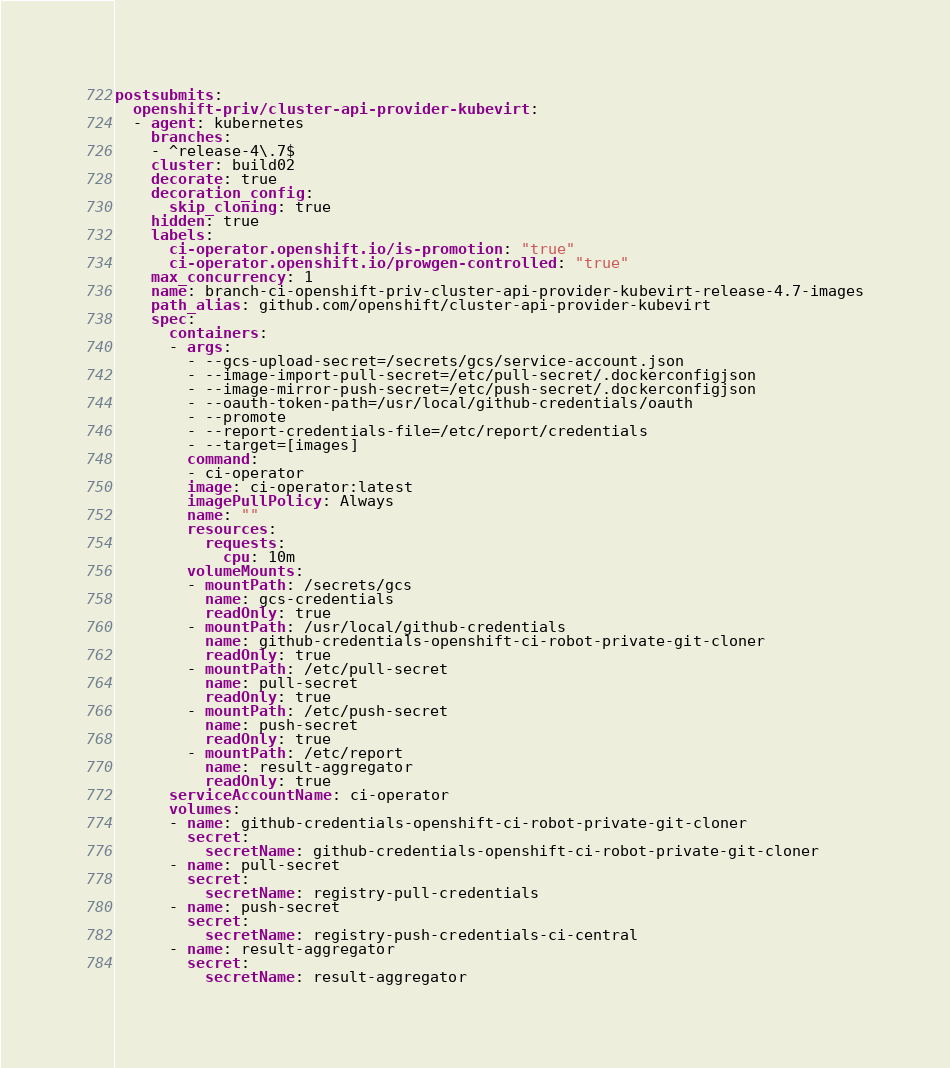<code> <loc_0><loc_0><loc_500><loc_500><_YAML_>postsubmits:
  openshift-priv/cluster-api-provider-kubevirt:
  - agent: kubernetes
    branches:
    - ^release-4\.7$
    cluster: build02
    decorate: true
    decoration_config:
      skip_cloning: true
    hidden: true
    labels:
      ci-operator.openshift.io/is-promotion: "true"
      ci-operator.openshift.io/prowgen-controlled: "true"
    max_concurrency: 1
    name: branch-ci-openshift-priv-cluster-api-provider-kubevirt-release-4.7-images
    path_alias: github.com/openshift/cluster-api-provider-kubevirt
    spec:
      containers:
      - args:
        - --gcs-upload-secret=/secrets/gcs/service-account.json
        - --image-import-pull-secret=/etc/pull-secret/.dockerconfigjson
        - --image-mirror-push-secret=/etc/push-secret/.dockerconfigjson
        - --oauth-token-path=/usr/local/github-credentials/oauth
        - --promote
        - --report-credentials-file=/etc/report/credentials
        - --target=[images]
        command:
        - ci-operator
        image: ci-operator:latest
        imagePullPolicy: Always
        name: ""
        resources:
          requests:
            cpu: 10m
        volumeMounts:
        - mountPath: /secrets/gcs
          name: gcs-credentials
          readOnly: true
        - mountPath: /usr/local/github-credentials
          name: github-credentials-openshift-ci-robot-private-git-cloner
          readOnly: true
        - mountPath: /etc/pull-secret
          name: pull-secret
          readOnly: true
        - mountPath: /etc/push-secret
          name: push-secret
          readOnly: true
        - mountPath: /etc/report
          name: result-aggregator
          readOnly: true
      serviceAccountName: ci-operator
      volumes:
      - name: github-credentials-openshift-ci-robot-private-git-cloner
        secret:
          secretName: github-credentials-openshift-ci-robot-private-git-cloner
      - name: pull-secret
        secret:
          secretName: registry-pull-credentials
      - name: push-secret
        secret:
          secretName: registry-push-credentials-ci-central
      - name: result-aggregator
        secret:
          secretName: result-aggregator
</code> 